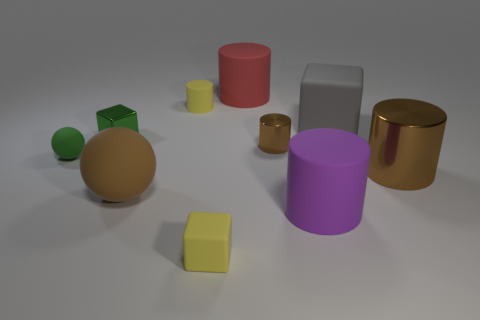Subtract all brown blocks. How many brown cylinders are left? 2 Subtract all small metal cylinders. How many cylinders are left? 4 Subtract all brown cylinders. How many cylinders are left? 3 Subtract all green cylinders. Subtract all red balls. How many cylinders are left? 5 Subtract all balls. How many objects are left? 8 Subtract 0 blue spheres. How many objects are left? 10 Subtract all big cyan objects. Subtract all green things. How many objects are left? 8 Add 8 small brown things. How many small brown things are left? 9 Add 7 large red objects. How many large red objects exist? 8 